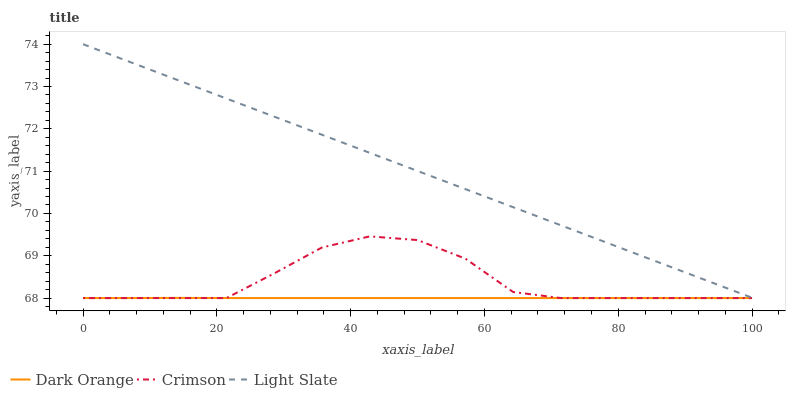Does Dark Orange have the minimum area under the curve?
Answer yes or no. Yes. Does Light Slate have the maximum area under the curve?
Answer yes or no. Yes. Does Light Slate have the minimum area under the curve?
Answer yes or no. No. Does Dark Orange have the maximum area under the curve?
Answer yes or no. No. Is Light Slate the smoothest?
Answer yes or no. Yes. Is Crimson the roughest?
Answer yes or no. Yes. Is Dark Orange the smoothest?
Answer yes or no. No. Is Dark Orange the roughest?
Answer yes or no. No. Does Crimson have the lowest value?
Answer yes or no. Yes. Does Light Slate have the lowest value?
Answer yes or no. No. Does Light Slate have the highest value?
Answer yes or no. Yes. Does Dark Orange have the highest value?
Answer yes or no. No. Is Dark Orange less than Light Slate?
Answer yes or no. Yes. Is Light Slate greater than Dark Orange?
Answer yes or no. Yes. Does Dark Orange intersect Crimson?
Answer yes or no. Yes. Is Dark Orange less than Crimson?
Answer yes or no. No. Is Dark Orange greater than Crimson?
Answer yes or no. No. Does Dark Orange intersect Light Slate?
Answer yes or no. No. 